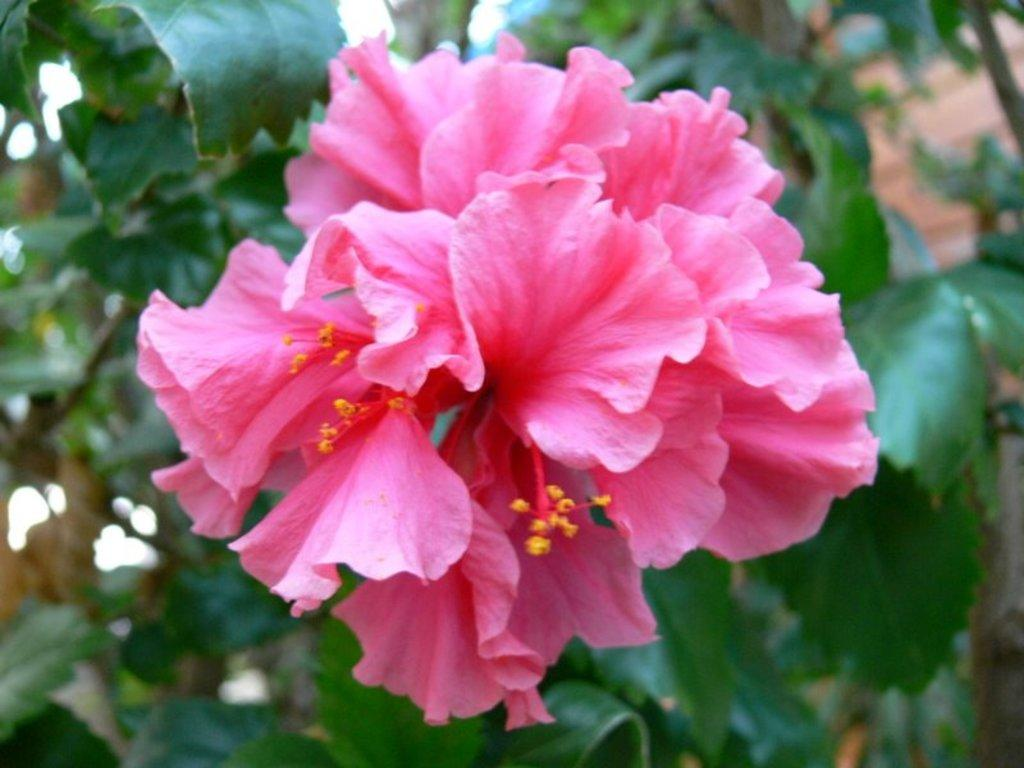What color are the flowers in the image? The flowers in the image are pink. What type of plant is visible in the image? There is a plant in the image. Can you describe the background of the image? The background of the image is blurred. How does the person in the image react to their new haircut? There is no person in the image, and therefore no haircut to react to. 